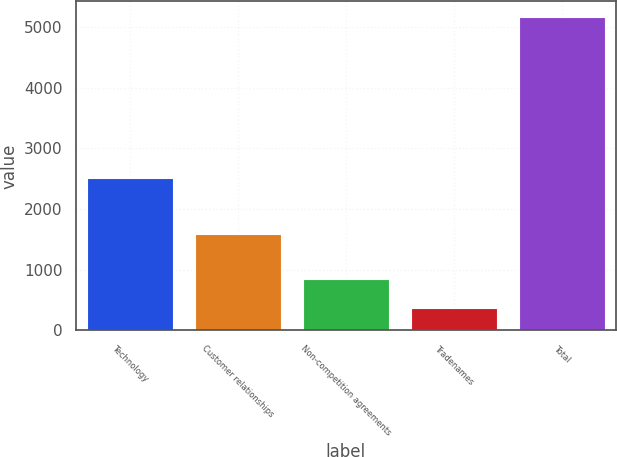<chart> <loc_0><loc_0><loc_500><loc_500><bar_chart><fcel>Technology<fcel>Customer relationships<fcel>Non-competition agreements<fcel>Tradenames<fcel>Total<nl><fcel>2505<fcel>1584<fcel>842.9<fcel>363<fcel>5162<nl></chart> 